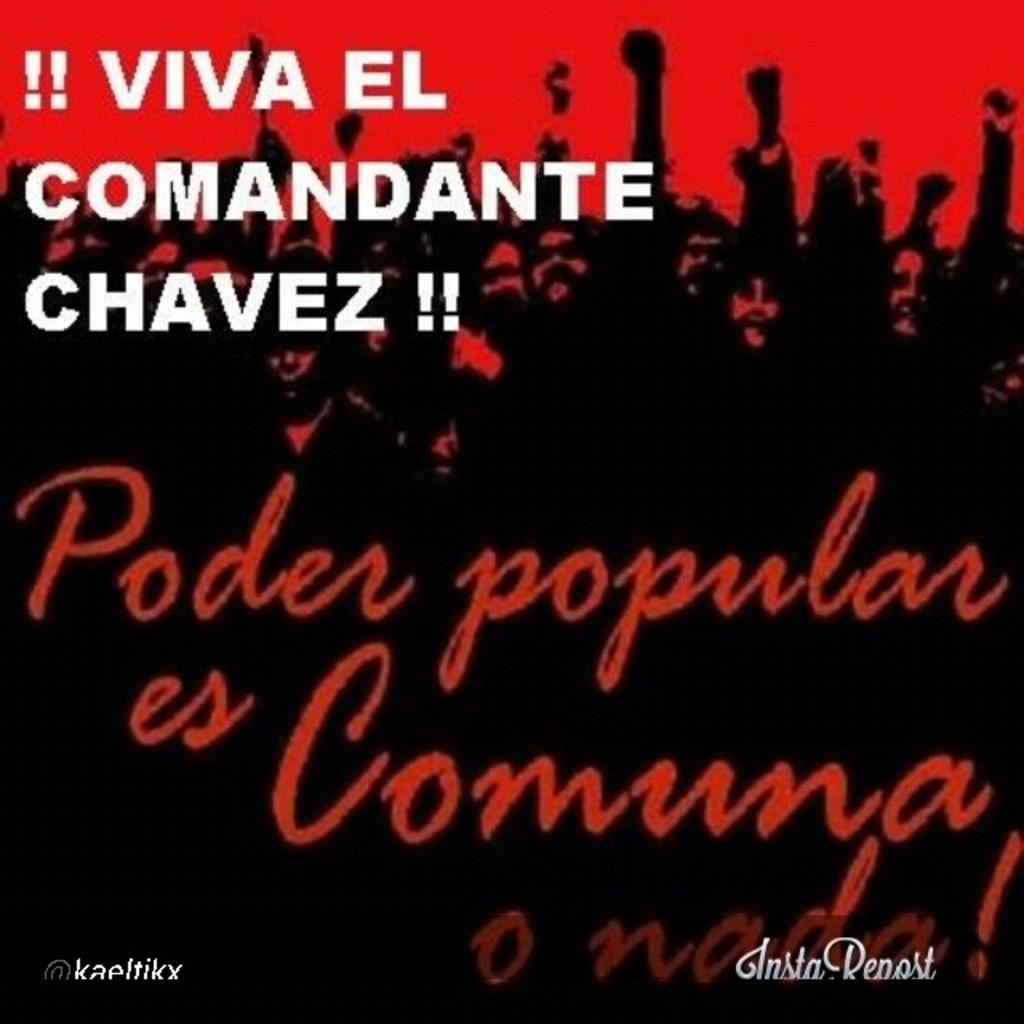What is featured on the poster in the image? There is a poster with text in the image. Can you describe the people present in the image? Unfortunately, the provided facts do not give any information about the people in the image. How many gates are visible in the image? There are no gates present in the image. What type of fork is being used by the person in the image? There is no person or fork present in the image. 